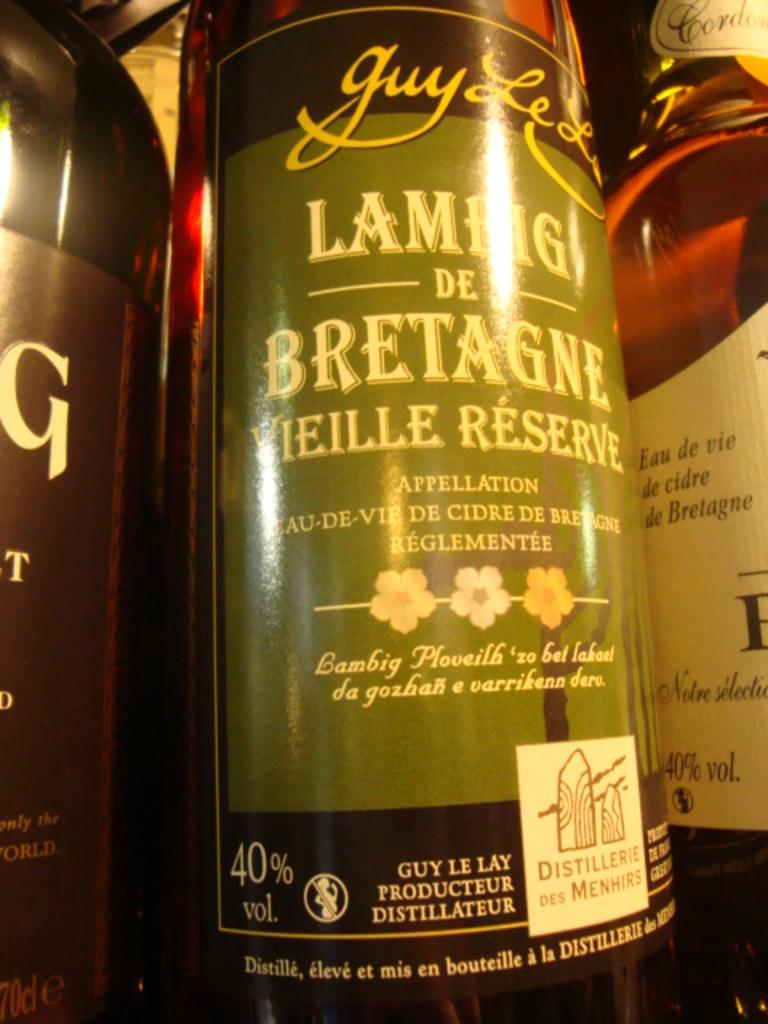<image>
Summarize the visual content of the image. A bottle with a green label the says LAMHG DE BRETAGNE VIELLE RESERVE with a 40% vol. alcohol content, 